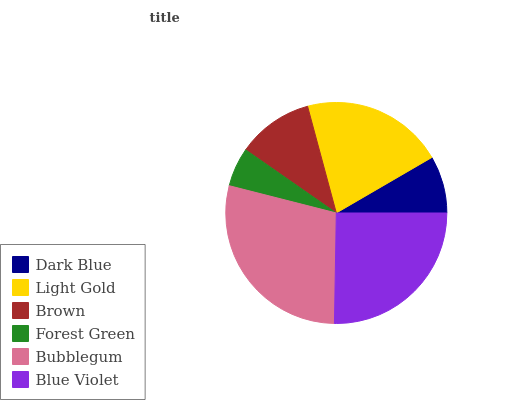Is Forest Green the minimum?
Answer yes or no. Yes. Is Bubblegum the maximum?
Answer yes or no. Yes. Is Light Gold the minimum?
Answer yes or no. No. Is Light Gold the maximum?
Answer yes or no. No. Is Light Gold greater than Dark Blue?
Answer yes or no. Yes. Is Dark Blue less than Light Gold?
Answer yes or no. Yes. Is Dark Blue greater than Light Gold?
Answer yes or no. No. Is Light Gold less than Dark Blue?
Answer yes or no. No. Is Light Gold the high median?
Answer yes or no. Yes. Is Brown the low median?
Answer yes or no. Yes. Is Forest Green the high median?
Answer yes or no. No. Is Bubblegum the low median?
Answer yes or no. No. 